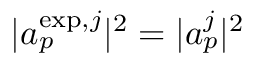<formula> <loc_0><loc_0><loc_500><loc_500>| a _ { p } ^ { e x p , j } | ^ { 2 } = | a _ { p } ^ { j } | ^ { 2 }</formula> 